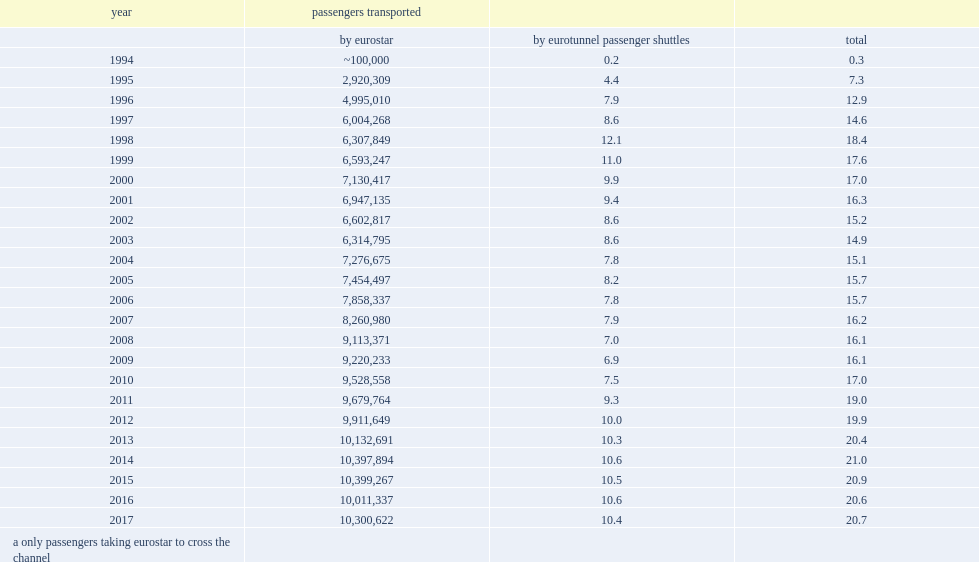What was the number of eurostar passengers in 2014? 10397894.0. 